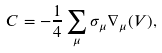Convert formula to latex. <formula><loc_0><loc_0><loc_500><loc_500>C = - \frac { 1 } { 4 } \sum _ { \mu } \sigma _ { \mu } \nabla _ { \mu } ( V ) ,</formula> 